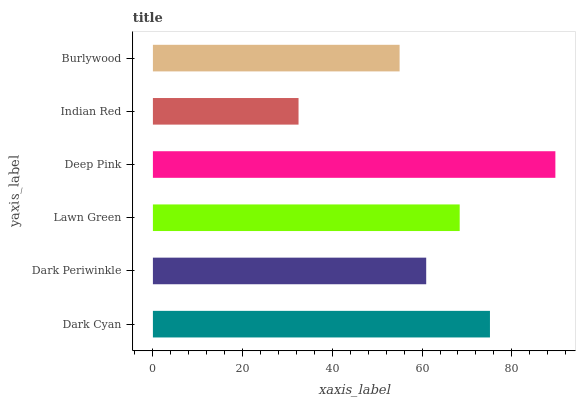Is Indian Red the minimum?
Answer yes or no. Yes. Is Deep Pink the maximum?
Answer yes or no. Yes. Is Dark Periwinkle the minimum?
Answer yes or no. No. Is Dark Periwinkle the maximum?
Answer yes or no. No. Is Dark Cyan greater than Dark Periwinkle?
Answer yes or no. Yes. Is Dark Periwinkle less than Dark Cyan?
Answer yes or no. Yes. Is Dark Periwinkle greater than Dark Cyan?
Answer yes or no. No. Is Dark Cyan less than Dark Periwinkle?
Answer yes or no. No. Is Lawn Green the high median?
Answer yes or no. Yes. Is Dark Periwinkle the low median?
Answer yes or no. Yes. Is Indian Red the high median?
Answer yes or no. No. Is Lawn Green the low median?
Answer yes or no. No. 